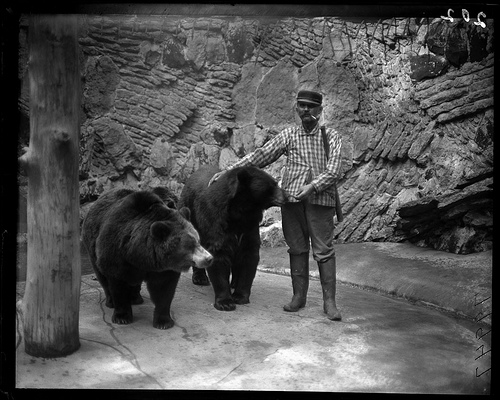How many bears are in the photo? 2 